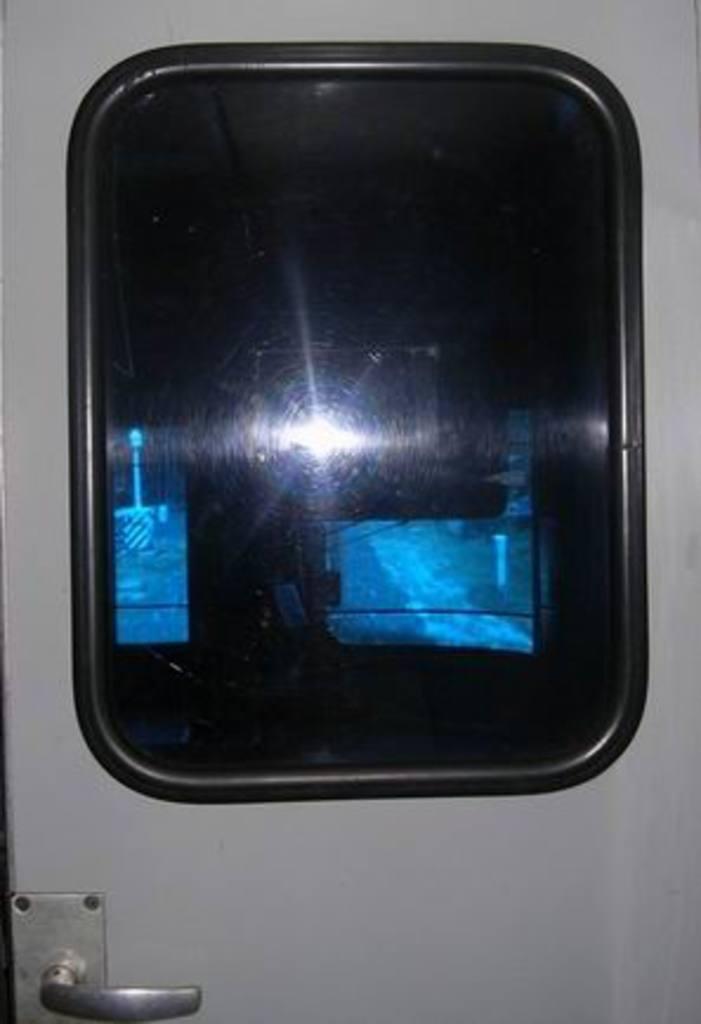Please provide a concise description of this image. In this image we can see a door with the handle. 